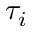Convert formula to latex. <formula><loc_0><loc_0><loc_500><loc_500>\tau _ { i }</formula> 